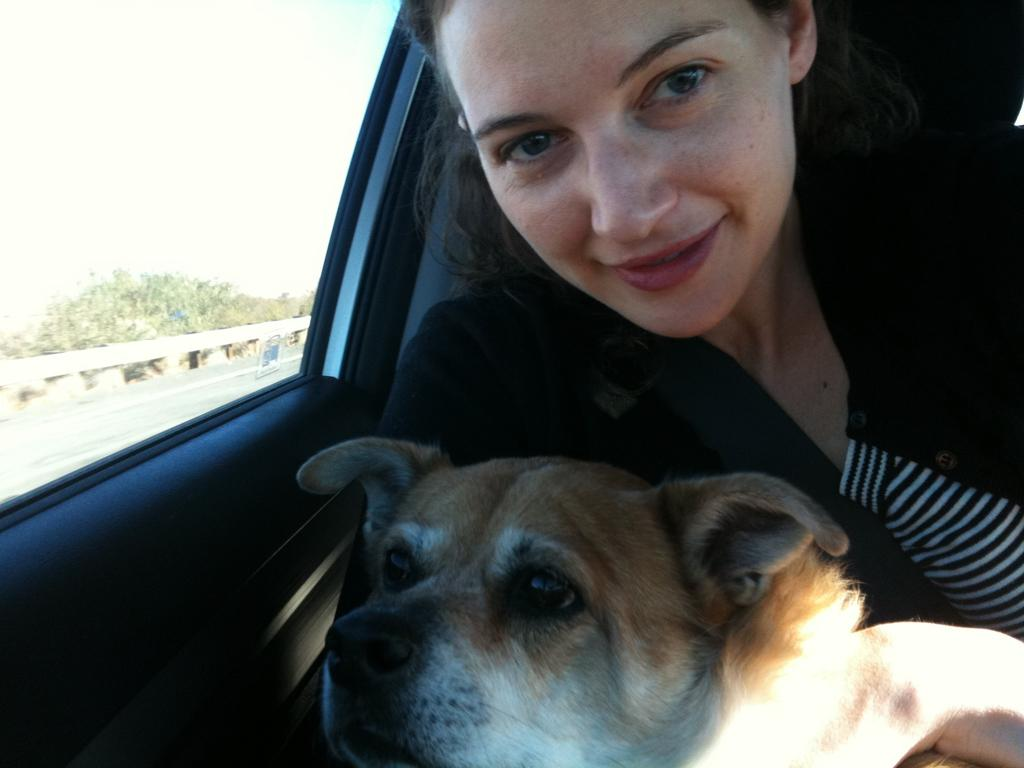What is the woman doing in the image? The woman is inside a vehicle in the image. What other living creature can be seen in the image? There is a dog in the image. What type of man-made structure is visible in the image? There is a road visible in the image. What type of natural environment is visible in the image? There are trees in the image. What part of the natural environment is visible in the image? The sky is visible in the image. What type of stage can be seen in the image? There is no stage present in the image. What type of control is the woman using to operate the vehicle in the image? The image does not show the specific controls being used by the woman to operate the vehicle. 